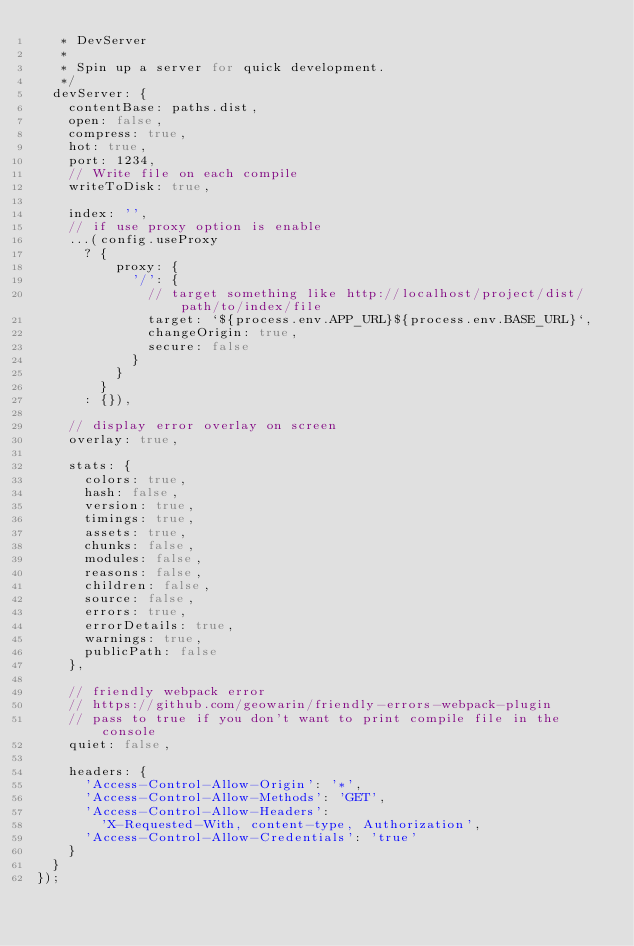<code> <loc_0><loc_0><loc_500><loc_500><_JavaScript_>   * DevServer
   *
   * Spin up a server for quick development.
   */
  devServer: {
    contentBase: paths.dist,
    open: false,
    compress: true,
    hot: true,
    port: 1234,
    // Write file on each compile
    writeToDisk: true,

    index: '',
    // if use proxy option is enable
    ...(config.useProxy
      ? {
          proxy: {
            '/': {
              // target something like http://localhost/project/dist/path/to/index/file
              target: `${process.env.APP_URL}${process.env.BASE_URL}`,
              changeOrigin: true,
              secure: false
            }
          }
        }
      : {}),

    // display error overlay on screen
    overlay: true,

    stats: {
      colors: true,
      hash: false,
      version: true,
      timings: true,
      assets: true,
      chunks: false,
      modules: false,
      reasons: false,
      children: false,
      source: false,
      errors: true,
      errorDetails: true,
      warnings: true,
      publicPath: false
    },

    // friendly webpack error
    // https://github.com/geowarin/friendly-errors-webpack-plugin
    // pass to true if you don't want to print compile file in the console
    quiet: false,

    headers: {
      'Access-Control-Allow-Origin': '*',
      'Access-Control-Allow-Methods': 'GET',
      'Access-Control-Allow-Headers':
        'X-Requested-With, content-type, Authorization',
      'Access-Control-Allow-Credentials': 'true'
    }
  }
});
</code> 